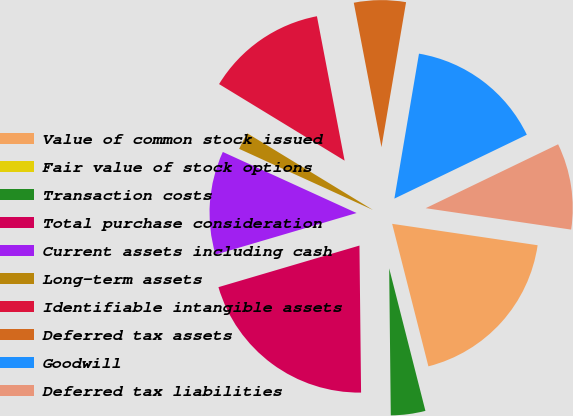Convert chart. <chart><loc_0><loc_0><loc_500><loc_500><pie_chart><fcel>Value of common stock issued<fcel>Fair value of stock options<fcel>Transaction costs<fcel>Total purchase consideration<fcel>Current assets including cash<fcel>Long-term assets<fcel>Identifiable intangible assets<fcel>Deferred tax assets<fcel>Goodwill<fcel>Deferred tax liabilities<nl><fcel>18.71%<fcel>0.0%<fcel>3.79%<fcel>20.61%<fcel>11.38%<fcel>1.9%<fcel>13.27%<fcel>5.69%<fcel>15.17%<fcel>9.48%<nl></chart> 